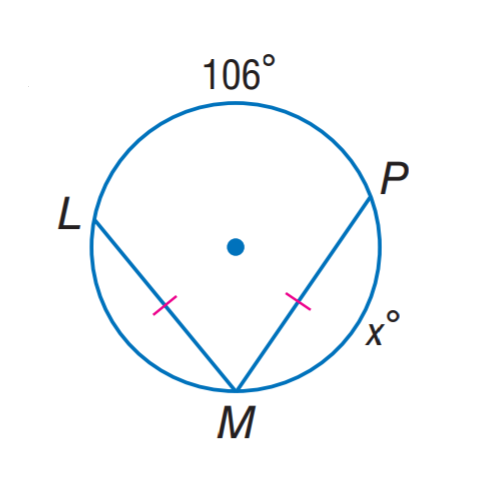Question: Find x.
Choices:
A. 53
B. 84
C. 106
D. 127
Answer with the letter. Answer: D 